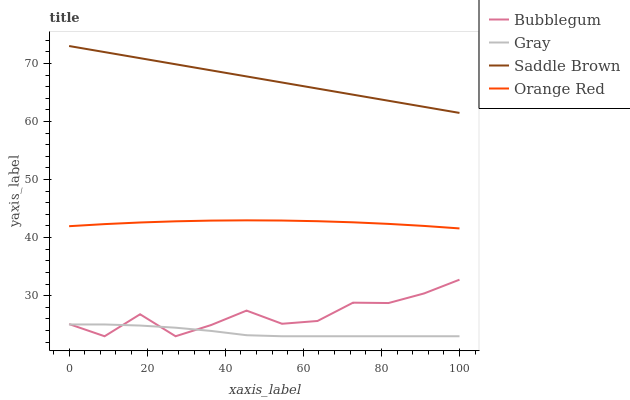Does Gray have the minimum area under the curve?
Answer yes or no. Yes. Does Saddle Brown have the maximum area under the curve?
Answer yes or no. Yes. Does Bubblegum have the minimum area under the curve?
Answer yes or no. No. Does Bubblegum have the maximum area under the curve?
Answer yes or no. No. Is Saddle Brown the smoothest?
Answer yes or no. Yes. Is Bubblegum the roughest?
Answer yes or no. Yes. Is Bubblegum the smoothest?
Answer yes or no. No. Is Saddle Brown the roughest?
Answer yes or no. No. Does Gray have the lowest value?
Answer yes or no. Yes. Does Saddle Brown have the lowest value?
Answer yes or no. No. Does Saddle Brown have the highest value?
Answer yes or no. Yes. Does Bubblegum have the highest value?
Answer yes or no. No. Is Gray less than Orange Red?
Answer yes or no. Yes. Is Orange Red greater than Bubblegum?
Answer yes or no. Yes. Does Gray intersect Bubblegum?
Answer yes or no. Yes. Is Gray less than Bubblegum?
Answer yes or no. No. Is Gray greater than Bubblegum?
Answer yes or no. No. Does Gray intersect Orange Red?
Answer yes or no. No. 